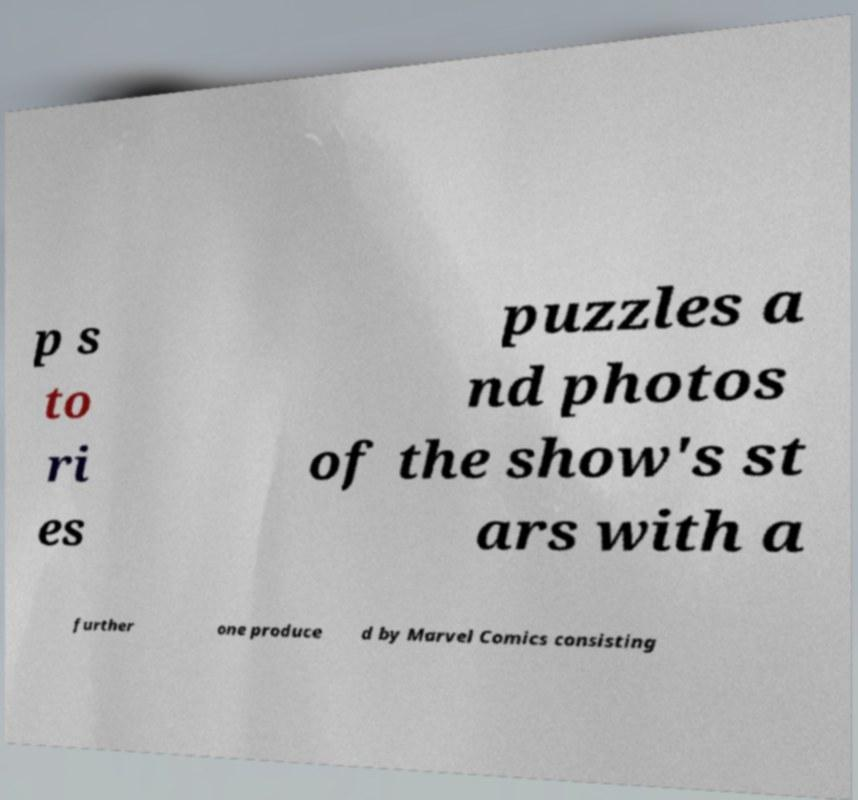What messages or text are displayed in this image? I need them in a readable, typed format. p s to ri es puzzles a nd photos of the show's st ars with a further one produce d by Marvel Comics consisting 